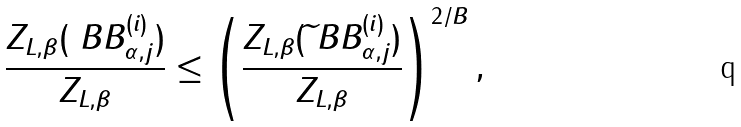<formula> <loc_0><loc_0><loc_500><loc_500>\frac { Z _ { L , \beta } ( \ B B _ { \alpha , j } ^ { ( i ) } ) } { Z _ { L , \beta } } \leq \left ( \frac { Z _ { L , \beta } ( \widetilde { \ } B B _ { \alpha , j } ^ { ( i ) } ) } { Z _ { L , \beta } } \right ) ^ { 2 / B } ,</formula> 